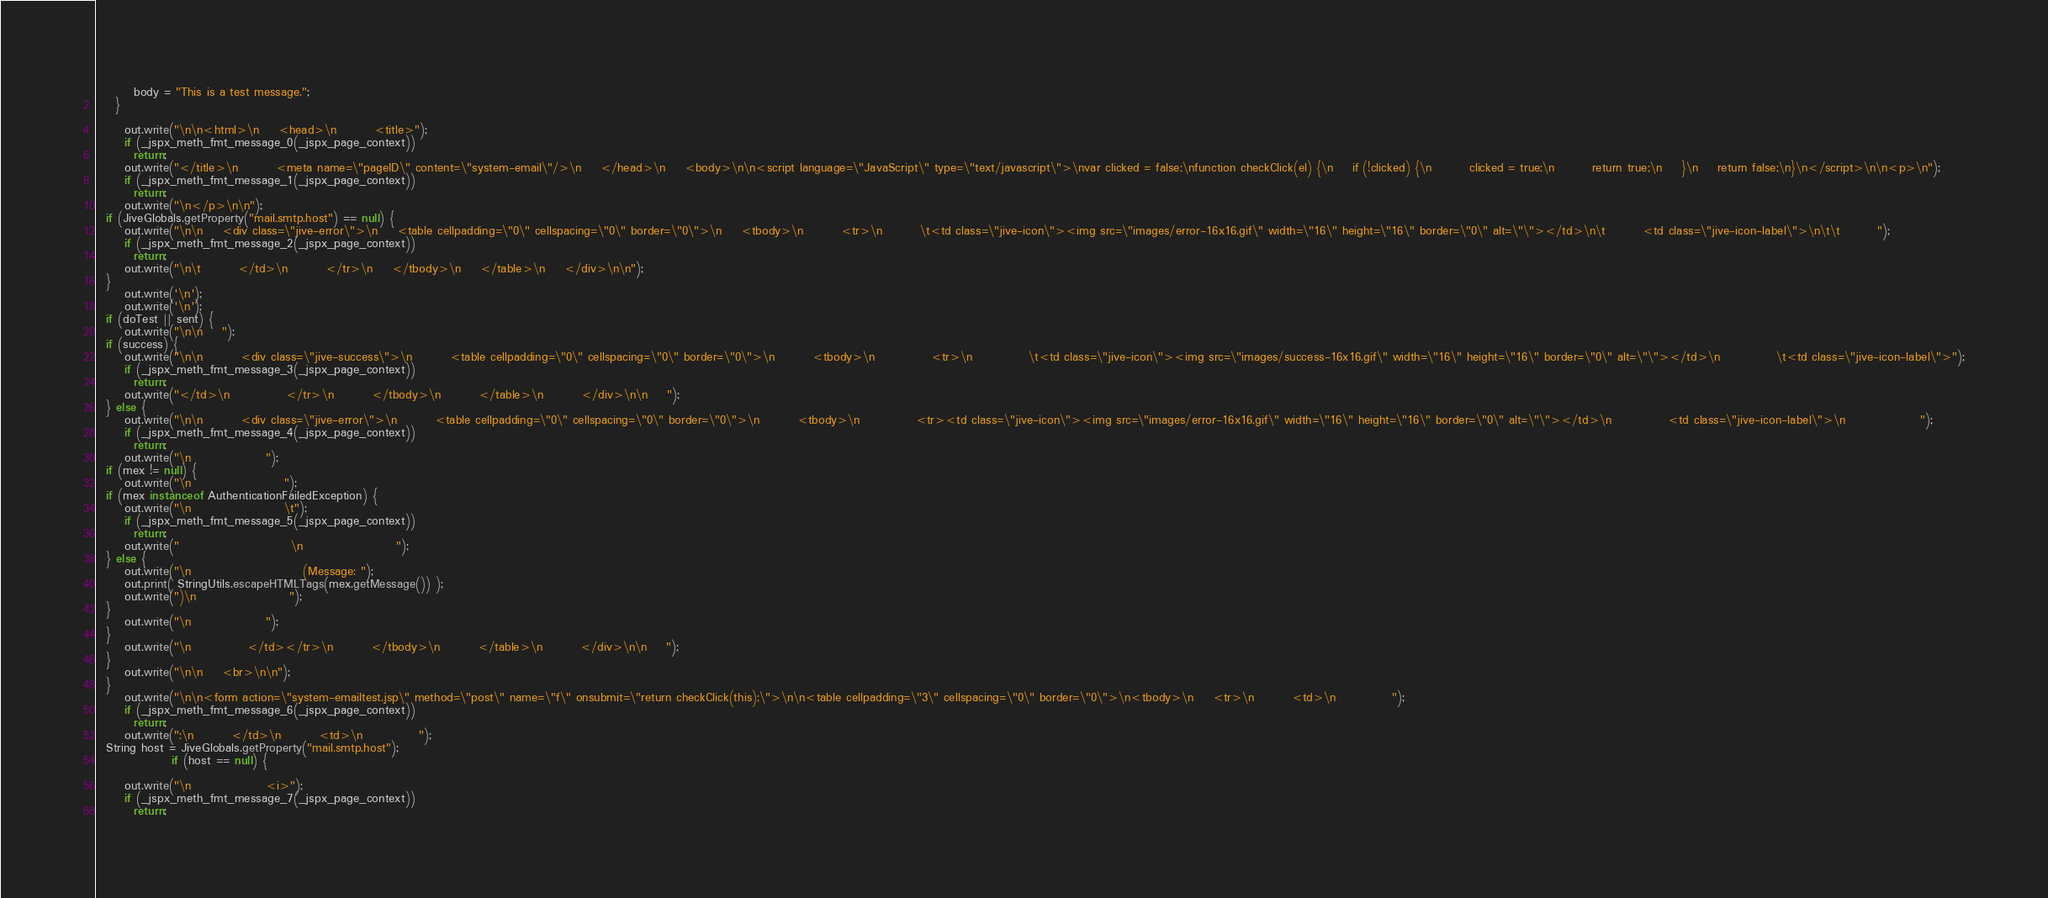<code> <loc_0><loc_0><loc_500><loc_500><_Java_>        body = "This is a test message.";
    }

      out.write("\n\n<html>\n    <head>\n        <title>");
      if (_jspx_meth_fmt_message_0(_jspx_page_context))
        return;
      out.write("</title>\n        <meta name=\"pageID\" content=\"system-email\"/>\n    </head>\n    <body>\n\n<script language=\"JavaScript\" type=\"text/javascript\">\nvar clicked = false;\nfunction checkClick(el) {\n    if (!clicked) {\n        clicked = true;\n        return true;\n    }\n    return false;\n}\n</script>\n\n<p>\n");
      if (_jspx_meth_fmt_message_1(_jspx_page_context))
        return;
      out.write("\n</p>\n\n");
  if (JiveGlobals.getProperty("mail.smtp.host") == null) { 
      out.write("\n\n    <div class=\"jive-error\">\n    <table cellpadding=\"0\" cellspacing=\"0\" border=\"0\">\n    <tbody>\n        <tr>\n        \t<td class=\"jive-icon\"><img src=\"images/error-16x16.gif\" width=\"16\" height=\"16\" border=\"0\" alt=\"\"></td>\n\t        <td class=\"jive-icon-label\">\n\t\t        ");
      if (_jspx_meth_fmt_message_2(_jspx_page_context))
        return;
      out.write("\n\t        </td>\n        </tr>\n    </tbody>\n    </table>\n    </div>\n\n");
  } 
      out.write('\n');
      out.write('\n');
  if (doTest || sent) { 
      out.write("\n\n    ");
  if (success) { 
      out.write("\n\n        <div class=\"jive-success\">\n        <table cellpadding=\"0\" cellspacing=\"0\" border=\"0\">\n        <tbody>\n            <tr>\n            \t<td class=\"jive-icon\"><img src=\"images/success-16x16.gif\" width=\"16\" height=\"16\" border=\"0\" alt=\"\"></td>\n            \t<td class=\"jive-icon-label\">");
      if (_jspx_meth_fmt_message_3(_jspx_page_context))
        return;
      out.write("</td>\n            </tr>\n        </tbody>\n        </table>\n        </div>\n\n    ");
  } else { 
      out.write("\n\n        <div class=\"jive-error\">\n        <table cellpadding=\"0\" cellspacing=\"0\" border=\"0\">\n        <tbody>\n            <tr><td class=\"jive-icon\"><img src=\"images/error-16x16.gif\" width=\"16\" height=\"16\" border=\"0\" alt=\"\"></td>\n            <td class=\"jive-icon-label\">\n                ");
      if (_jspx_meth_fmt_message_4(_jspx_page_context))
        return;
      out.write("\n                ");
  if (mex != null) { 
      out.write("\n                    ");
  if (mex instanceof AuthenticationFailedException) { 
      out.write("\n                    \t");
      if (_jspx_meth_fmt_message_5(_jspx_page_context))
        return;
      out.write("                        \n                    ");
  } else { 
      out.write("\n                        (Message: ");
      out.print( StringUtils.escapeHTMLTags(mex.getMessage()) );
      out.write(")\n                    ");
  } 
      out.write("\n                ");
  } 
      out.write("\n            </td></tr>\n        </tbody>\n        </table>\n        </div>\n\n    ");
  } 
      out.write("\n\n    <br>\n\n");
  } 
      out.write("\n\n<form action=\"system-emailtest.jsp\" method=\"post\" name=\"f\" onsubmit=\"return checkClick(this);\">\n\n<table cellpadding=\"3\" cellspacing=\"0\" border=\"0\">\n<tbody>\n    <tr>\n        <td>\n            ");
      if (_jspx_meth_fmt_message_6(_jspx_page_context))
        return;
      out.write(":\n        </td>\n        <td>\n            ");
  String host = JiveGlobals.getProperty("mail.smtp.host");
                if (host == null) {
            
      out.write("\n                <i>");
      if (_jspx_meth_fmt_message_7(_jspx_page_context))
        return;</code> 